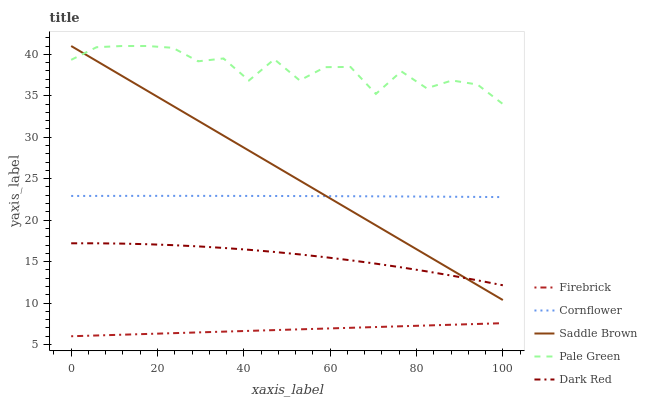Does Firebrick have the minimum area under the curve?
Answer yes or no. Yes. Does Pale Green have the maximum area under the curve?
Answer yes or no. Yes. Does Pale Green have the minimum area under the curve?
Answer yes or no. No. Does Firebrick have the maximum area under the curve?
Answer yes or no. No. Is Firebrick the smoothest?
Answer yes or no. Yes. Is Pale Green the roughest?
Answer yes or no. Yes. Is Pale Green the smoothest?
Answer yes or no. No. Is Firebrick the roughest?
Answer yes or no. No. Does Firebrick have the lowest value?
Answer yes or no. Yes. Does Pale Green have the lowest value?
Answer yes or no. No. Does Saddle Brown have the highest value?
Answer yes or no. Yes. Does Firebrick have the highest value?
Answer yes or no. No. Is Cornflower less than Pale Green?
Answer yes or no. Yes. Is Cornflower greater than Dark Red?
Answer yes or no. Yes. Does Saddle Brown intersect Cornflower?
Answer yes or no. Yes. Is Saddle Brown less than Cornflower?
Answer yes or no. No. Is Saddle Brown greater than Cornflower?
Answer yes or no. No. Does Cornflower intersect Pale Green?
Answer yes or no. No. 